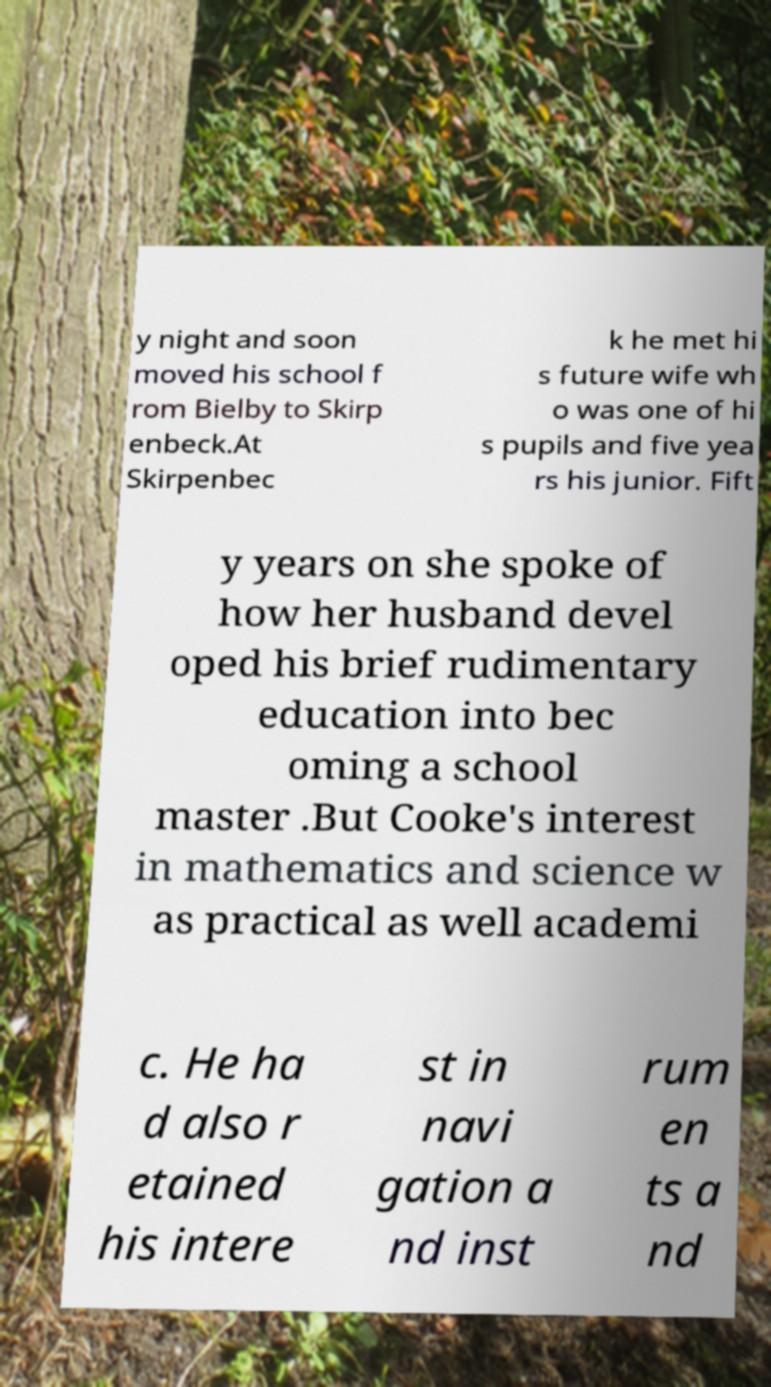Please read and relay the text visible in this image. What does it say? y night and soon moved his school f rom Bielby to Skirp enbeck.At Skirpenbec k he met hi s future wife wh o was one of hi s pupils and five yea rs his junior. Fift y years on she spoke of how her husband devel oped his brief rudimentary education into bec oming a school master .But Cooke's interest in mathematics and science w as practical as well academi c. He ha d also r etained his intere st in navi gation a nd inst rum en ts a nd 